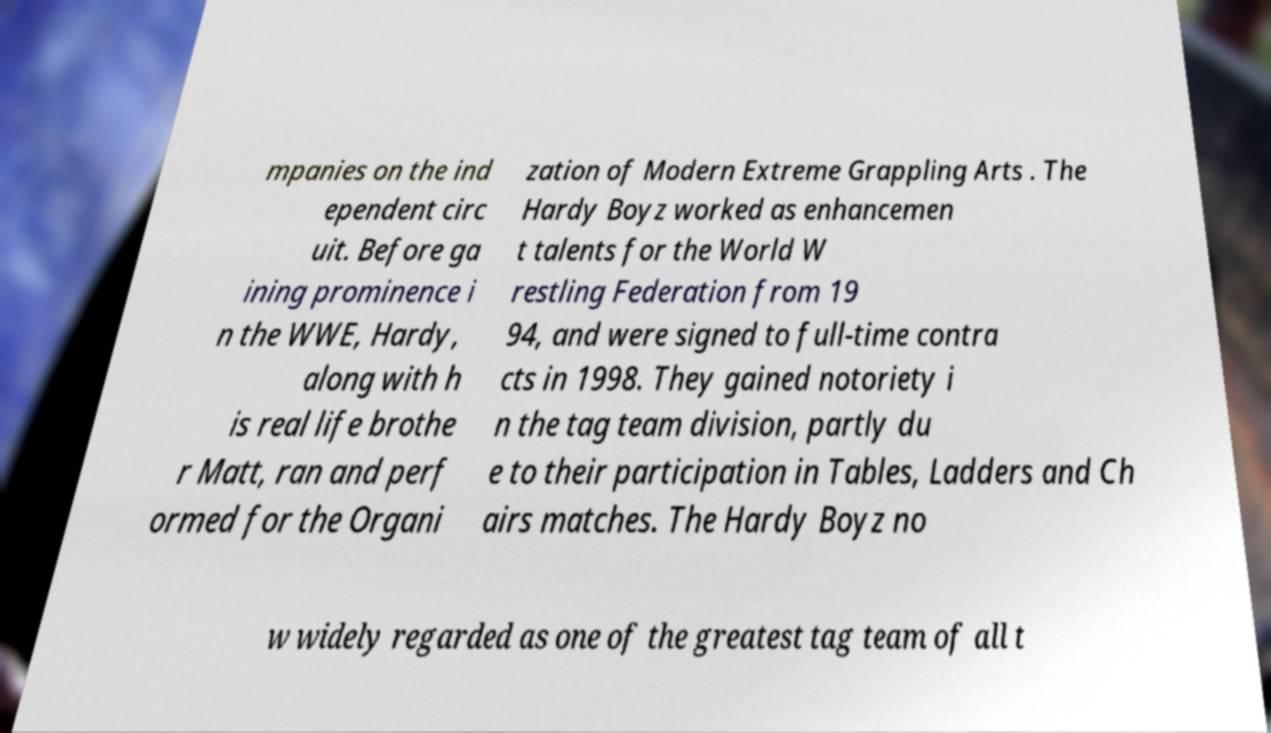For documentation purposes, I need the text within this image transcribed. Could you provide that? mpanies on the ind ependent circ uit. Before ga ining prominence i n the WWE, Hardy, along with h is real life brothe r Matt, ran and perf ormed for the Organi zation of Modern Extreme Grappling Arts . The Hardy Boyz worked as enhancemen t talents for the World W restling Federation from 19 94, and were signed to full-time contra cts in 1998. They gained notoriety i n the tag team division, partly du e to their participation in Tables, Ladders and Ch airs matches. The Hardy Boyz no w widely regarded as one of the greatest tag team of all t 